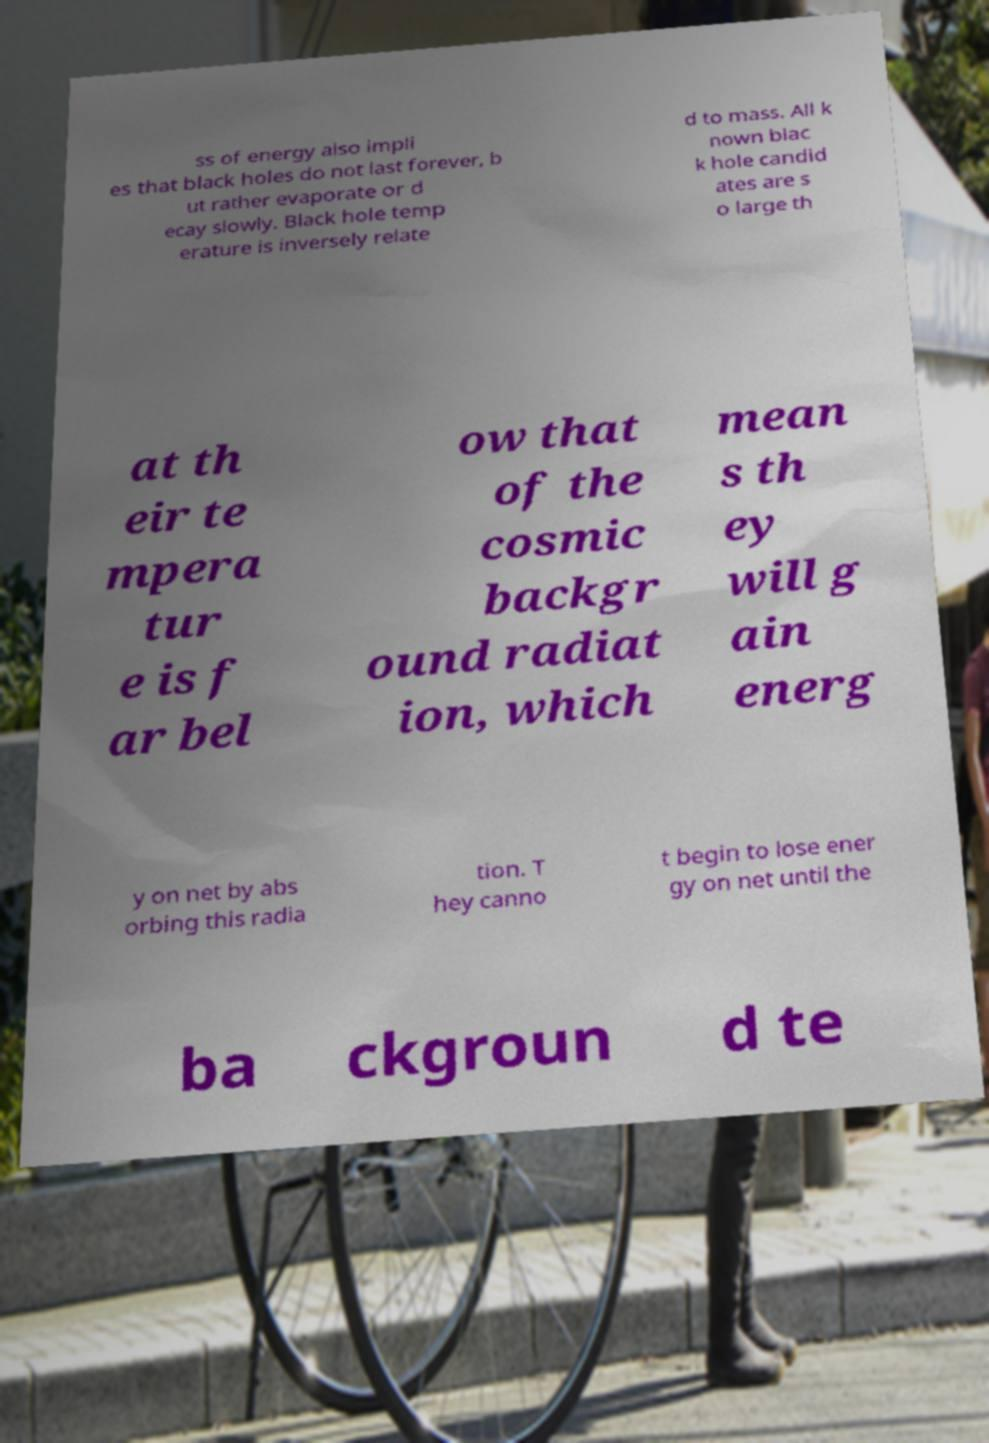Could you extract and type out the text from this image? ss of energy also impli es that black holes do not last forever, b ut rather evaporate or d ecay slowly. Black hole temp erature is inversely relate d to mass. All k nown blac k hole candid ates are s o large th at th eir te mpera tur e is f ar bel ow that of the cosmic backgr ound radiat ion, which mean s th ey will g ain energ y on net by abs orbing this radia tion. T hey canno t begin to lose ener gy on net until the ba ckgroun d te 